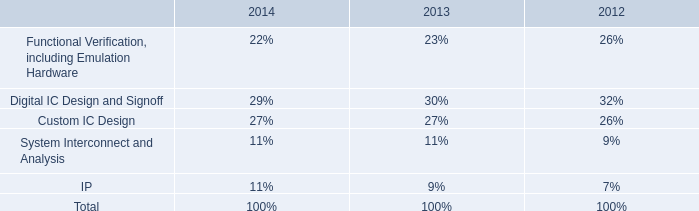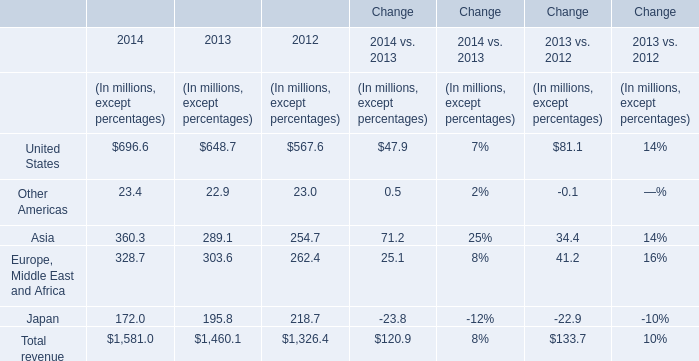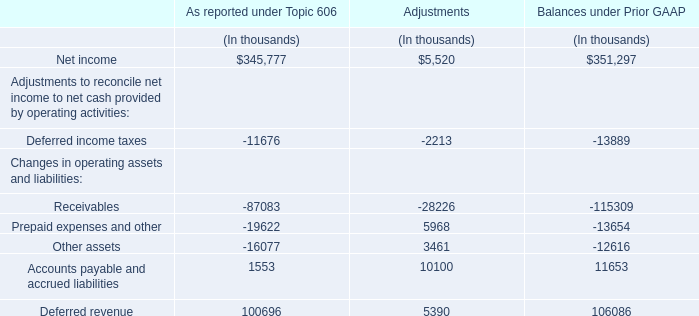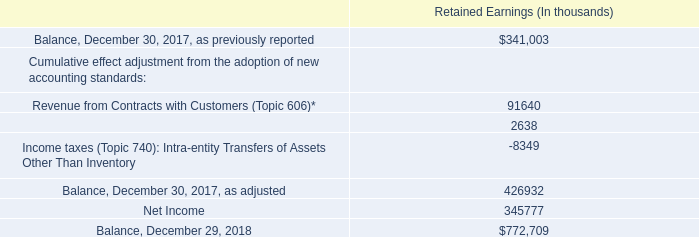what is the percentage change in the balance of retained earnings during 2018 after adjustments? 
Computations: ((772709 - 426932) / 426932)
Answer: 0.80991. 